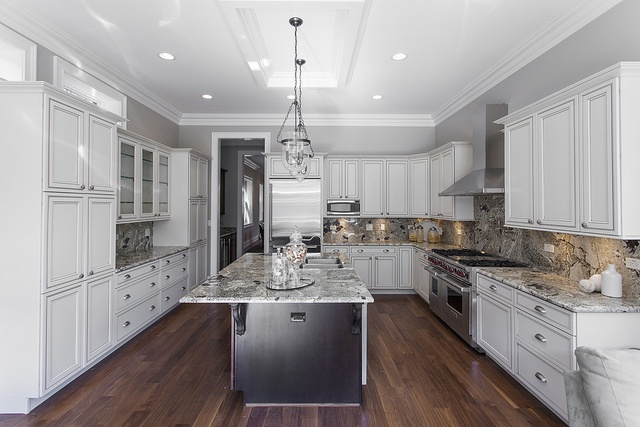Describe the objects in this image and their specific colors. I can see dining table in lightgray, darkgray, gray, and black tones, couch in lightgray, darkgray, and gray tones, oven in lightgray, black, and gray tones, refrigerator in lightgray, darkgray, gray, and black tones, and bottle in lightgray, darkgray, and gray tones in this image. 